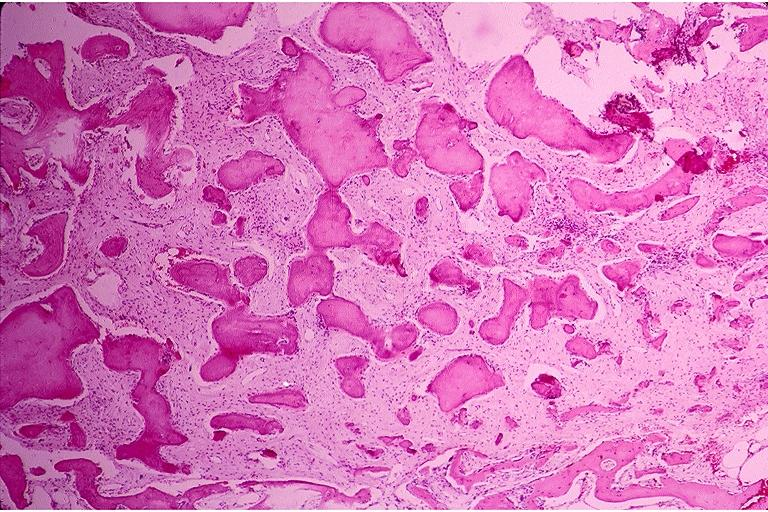what does this image show?
Answer the question using a single word or phrase. Benign fibro-osseous lesion 